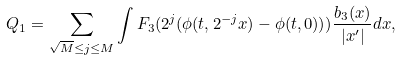Convert formula to latex. <formula><loc_0><loc_0><loc_500><loc_500>Q _ { 1 } = \sum _ { \sqrt { M } \leq j \leq M } \int F _ { 3 } ( 2 ^ { j } ( \phi ( t , 2 ^ { - j } x ) - \phi ( t , 0 ) ) ) \frac { b _ { 3 } ( x ) } { | x ^ { \prime } | } d x ,</formula> 